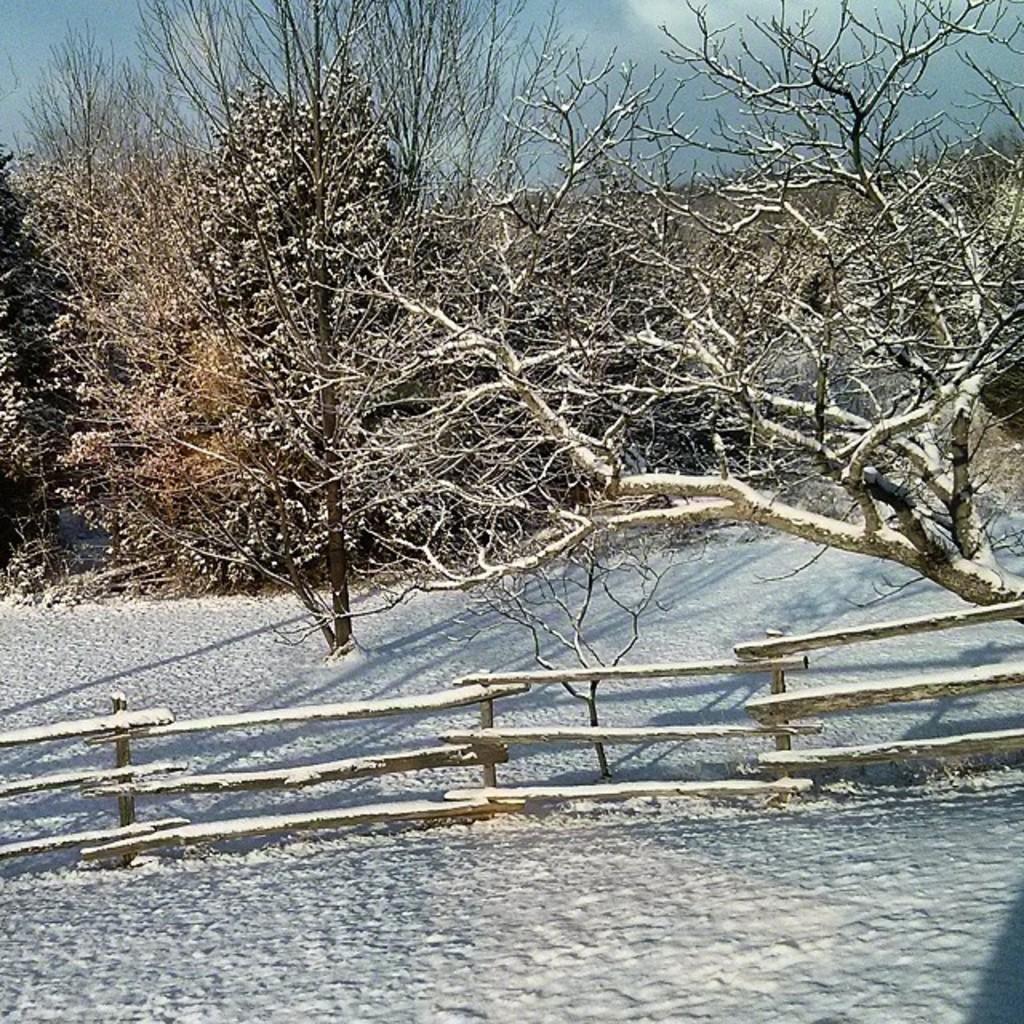Could you give a brief overview of what you see in this image? In this picture we can see snow, wooden fence and few trees. 